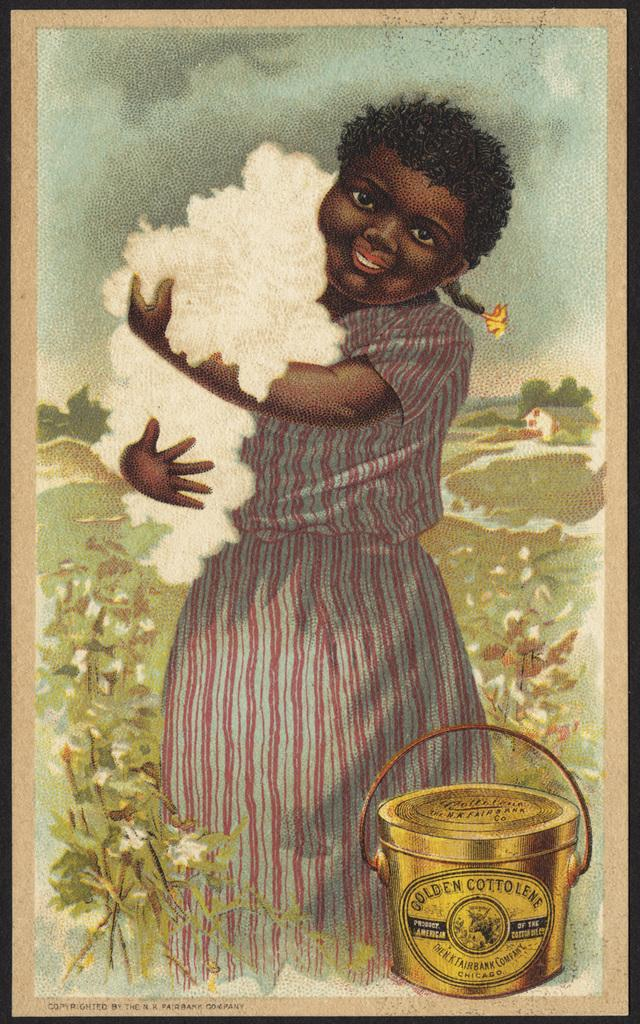<image>
Offer a succinct explanation of the picture presented. Woman holding some cotton near a bucket that says Golden Cottolene. 